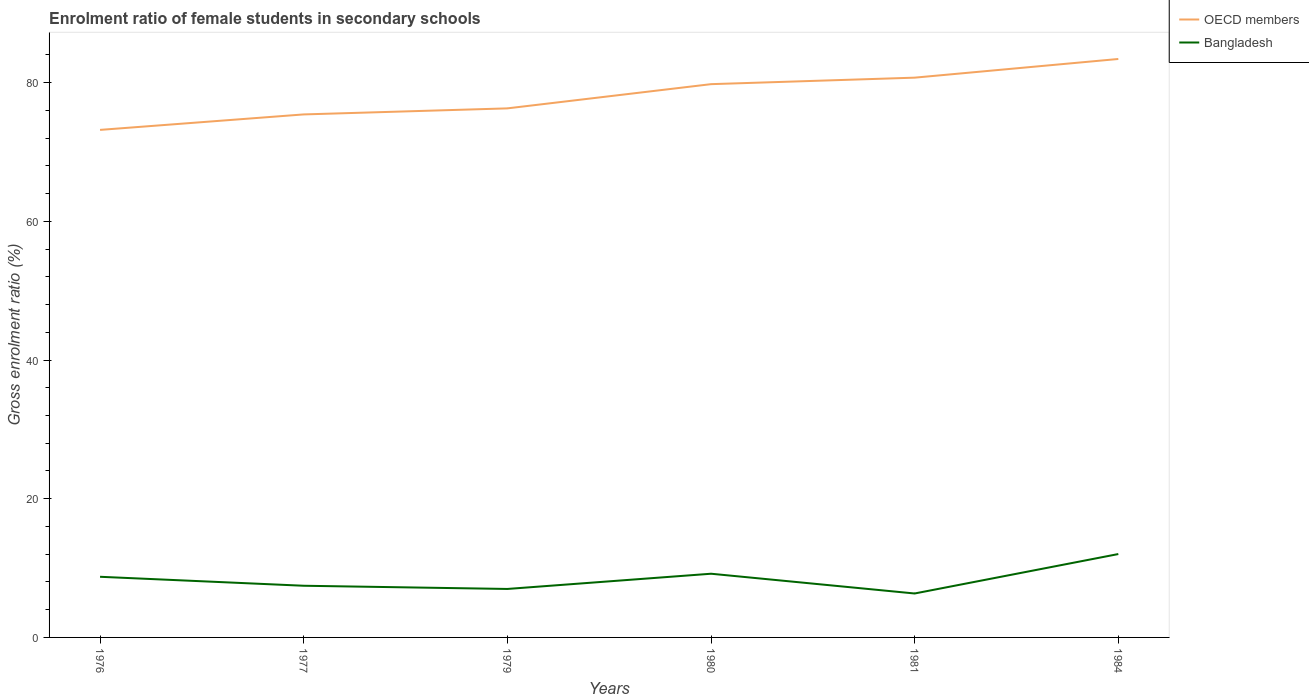Across all years, what is the maximum enrolment ratio of female students in secondary schools in Bangladesh?
Your answer should be compact. 6.34. In which year was the enrolment ratio of female students in secondary schools in Bangladesh maximum?
Ensure brevity in your answer.  1981. What is the total enrolment ratio of female students in secondary schools in Bangladesh in the graph?
Make the answer very short. -5.03. What is the difference between the highest and the second highest enrolment ratio of female students in secondary schools in Bangladesh?
Your response must be concise. 5.69. What is the difference between the highest and the lowest enrolment ratio of female students in secondary schools in OECD members?
Provide a succinct answer. 3. Is the enrolment ratio of female students in secondary schools in OECD members strictly greater than the enrolment ratio of female students in secondary schools in Bangladesh over the years?
Ensure brevity in your answer.  No. How many years are there in the graph?
Make the answer very short. 6. What is the difference between two consecutive major ticks on the Y-axis?
Make the answer very short. 20. Does the graph contain any zero values?
Keep it short and to the point. No. Where does the legend appear in the graph?
Your response must be concise. Top right. How are the legend labels stacked?
Give a very brief answer. Vertical. What is the title of the graph?
Provide a succinct answer. Enrolment ratio of female students in secondary schools. What is the Gross enrolment ratio (%) in OECD members in 1976?
Provide a succinct answer. 73.18. What is the Gross enrolment ratio (%) in Bangladesh in 1976?
Ensure brevity in your answer.  8.74. What is the Gross enrolment ratio (%) of OECD members in 1977?
Your response must be concise. 75.41. What is the Gross enrolment ratio (%) of Bangladesh in 1977?
Make the answer very short. 7.45. What is the Gross enrolment ratio (%) in OECD members in 1979?
Offer a terse response. 76.29. What is the Gross enrolment ratio (%) in Bangladesh in 1979?
Provide a succinct answer. 6.99. What is the Gross enrolment ratio (%) of OECD members in 1980?
Give a very brief answer. 79.78. What is the Gross enrolment ratio (%) in Bangladesh in 1980?
Offer a terse response. 9.18. What is the Gross enrolment ratio (%) of OECD members in 1981?
Keep it short and to the point. 80.71. What is the Gross enrolment ratio (%) of Bangladesh in 1981?
Ensure brevity in your answer.  6.34. What is the Gross enrolment ratio (%) of OECD members in 1984?
Keep it short and to the point. 83.41. What is the Gross enrolment ratio (%) in Bangladesh in 1984?
Make the answer very short. 12.02. Across all years, what is the maximum Gross enrolment ratio (%) of OECD members?
Your response must be concise. 83.41. Across all years, what is the maximum Gross enrolment ratio (%) of Bangladesh?
Your answer should be compact. 12.02. Across all years, what is the minimum Gross enrolment ratio (%) in OECD members?
Your answer should be compact. 73.18. Across all years, what is the minimum Gross enrolment ratio (%) of Bangladesh?
Make the answer very short. 6.34. What is the total Gross enrolment ratio (%) of OECD members in the graph?
Your answer should be very brief. 468.79. What is the total Gross enrolment ratio (%) of Bangladesh in the graph?
Your answer should be very brief. 50.73. What is the difference between the Gross enrolment ratio (%) of OECD members in 1976 and that in 1977?
Your answer should be compact. -2.23. What is the difference between the Gross enrolment ratio (%) in Bangladesh in 1976 and that in 1977?
Keep it short and to the point. 1.29. What is the difference between the Gross enrolment ratio (%) of OECD members in 1976 and that in 1979?
Make the answer very short. -3.1. What is the difference between the Gross enrolment ratio (%) of Bangladesh in 1976 and that in 1979?
Give a very brief answer. 1.75. What is the difference between the Gross enrolment ratio (%) of OECD members in 1976 and that in 1980?
Make the answer very short. -6.59. What is the difference between the Gross enrolment ratio (%) of Bangladesh in 1976 and that in 1980?
Offer a terse response. -0.44. What is the difference between the Gross enrolment ratio (%) in OECD members in 1976 and that in 1981?
Your response must be concise. -7.53. What is the difference between the Gross enrolment ratio (%) in Bangladesh in 1976 and that in 1981?
Offer a very short reply. 2.41. What is the difference between the Gross enrolment ratio (%) in OECD members in 1976 and that in 1984?
Make the answer very short. -10.22. What is the difference between the Gross enrolment ratio (%) in Bangladesh in 1976 and that in 1984?
Provide a short and direct response. -3.28. What is the difference between the Gross enrolment ratio (%) of OECD members in 1977 and that in 1979?
Provide a short and direct response. -0.87. What is the difference between the Gross enrolment ratio (%) in Bangladesh in 1977 and that in 1979?
Your answer should be compact. 0.46. What is the difference between the Gross enrolment ratio (%) in OECD members in 1977 and that in 1980?
Provide a short and direct response. -4.36. What is the difference between the Gross enrolment ratio (%) of Bangladesh in 1977 and that in 1980?
Make the answer very short. -1.73. What is the difference between the Gross enrolment ratio (%) in Bangladesh in 1977 and that in 1981?
Keep it short and to the point. 1.12. What is the difference between the Gross enrolment ratio (%) in OECD members in 1977 and that in 1984?
Ensure brevity in your answer.  -7.99. What is the difference between the Gross enrolment ratio (%) in Bangladesh in 1977 and that in 1984?
Provide a succinct answer. -4.57. What is the difference between the Gross enrolment ratio (%) of OECD members in 1979 and that in 1980?
Offer a terse response. -3.49. What is the difference between the Gross enrolment ratio (%) in Bangladesh in 1979 and that in 1980?
Your answer should be very brief. -2.19. What is the difference between the Gross enrolment ratio (%) of OECD members in 1979 and that in 1981?
Offer a terse response. -4.43. What is the difference between the Gross enrolment ratio (%) of Bangladesh in 1979 and that in 1981?
Provide a succinct answer. 0.65. What is the difference between the Gross enrolment ratio (%) of OECD members in 1979 and that in 1984?
Provide a short and direct response. -7.12. What is the difference between the Gross enrolment ratio (%) of Bangladesh in 1979 and that in 1984?
Provide a short and direct response. -5.03. What is the difference between the Gross enrolment ratio (%) of OECD members in 1980 and that in 1981?
Give a very brief answer. -0.94. What is the difference between the Gross enrolment ratio (%) in Bangladesh in 1980 and that in 1981?
Your answer should be very brief. 2.85. What is the difference between the Gross enrolment ratio (%) in OECD members in 1980 and that in 1984?
Ensure brevity in your answer.  -3.63. What is the difference between the Gross enrolment ratio (%) of Bangladesh in 1980 and that in 1984?
Offer a terse response. -2.84. What is the difference between the Gross enrolment ratio (%) in OECD members in 1981 and that in 1984?
Provide a short and direct response. -2.69. What is the difference between the Gross enrolment ratio (%) in Bangladesh in 1981 and that in 1984?
Make the answer very short. -5.69. What is the difference between the Gross enrolment ratio (%) in OECD members in 1976 and the Gross enrolment ratio (%) in Bangladesh in 1977?
Give a very brief answer. 65.73. What is the difference between the Gross enrolment ratio (%) of OECD members in 1976 and the Gross enrolment ratio (%) of Bangladesh in 1979?
Provide a short and direct response. 66.19. What is the difference between the Gross enrolment ratio (%) in OECD members in 1976 and the Gross enrolment ratio (%) in Bangladesh in 1980?
Give a very brief answer. 64. What is the difference between the Gross enrolment ratio (%) of OECD members in 1976 and the Gross enrolment ratio (%) of Bangladesh in 1981?
Make the answer very short. 66.85. What is the difference between the Gross enrolment ratio (%) of OECD members in 1976 and the Gross enrolment ratio (%) of Bangladesh in 1984?
Provide a succinct answer. 61.16. What is the difference between the Gross enrolment ratio (%) in OECD members in 1977 and the Gross enrolment ratio (%) in Bangladesh in 1979?
Your answer should be compact. 68.42. What is the difference between the Gross enrolment ratio (%) of OECD members in 1977 and the Gross enrolment ratio (%) of Bangladesh in 1980?
Keep it short and to the point. 66.23. What is the difference between the Gross enrolment ratio (%) in OECD members in 1977 and the Gross enrolment ratio (%) in Bangladesh in 1981?
Offer a very short reply. 69.08. What is the difference between the Gross enrolment ratio (%) in OECD members in 1977 and the Gross enrolment ratio (%) in Bangladesh in 1984?
Provide a short and direct response. 63.39. What is the difference between the Gross enrolment ratio (%) of OECD members in 1979 and the Gross enrolment ratio (%) of Bangladesh in 1980?
Your answer should be very brief. 67.1. What is the difference between the Gross enrolment ratio (%) in OECD members in 1979 and the Gross enrolment ratio (%) in Bangladesh in 1981?
Your response must be concise. 69.95. What is the difference between the Gross enrolment ratio (%) in OECD members in 1979 and the Gross enrolment ratio (%) in Bangladesh in 1984?
Ensure brevity in your answer.  64.26. What is the difference between the Gross enrolment ratio (%) in OECD members in 1980 and the Gross enrolment ratio (%) in Bangladesh in 1981?
Offer a terse response. 73.44. What is the difference between the Gross enrolment ratio (%) of OECD members in 1980 and the Gross enrolment ratio (%) of Bangladesh in 1984?
Your answer should be very brief. 67.75. What is the difference between the Gross enrolment ratio (%) in OECD members in 1981 and the Gross enrolment ratio (%) in Bangladesh in 1984?
Provide a short and direct response. 68.69. What is the average Gross enrolment ratio (%) of OECD members per year?
Provide a succinct answer. 78.13. What is the average Gross enrolment ratio (%) in Bangladesh per year?
Your response must be concise. 8.45. In the year 1976, what is the difference between the Gross enrolment ratio (%) in OECD members and Gross enrolment ratio (%) in Bangladesh?
Make the answer very short. 64.44. In the year 1977, what is the difference between the Gross enrolment ratio (%) of OECD members and Gross enrolment ratio (%) of Bangladesh?
Provide a short and direct response. 67.96. In the year 1979, what is the difference between the Gross enrolment ratio (%) of OECD members and Gross enrolment ratio (%) of Bangladesh?
Provide a short and direct response. 69.3. In the year 1980, what is the difference between the Gross enrolment ratio (%) in OECD members and Gross enrolment ratio (%) in Bangladesh?
Provide a short and direct response. 70.59. In the year 1981, what is the difference between the Gross enrolment ratio (%) of OECD members and Gross enrolment ratio (%) of Bangladesh?
Provide a succinct answer. 74.38. In the year 1984, what is the difference between the Gross enrolment ratio (%) in OECD members and Gross enrolment ratio (%) in Bangladesh?
Provide a short and direct response. 71.39. What is the ratio of the Gross enrolment ratio (%) in OECD members in 1976 to that in 1977?
Provide a succinct answer. 0.97. What is the ratio of the Gross enrolment ratio (%) in Bangladesh in 1976 to that in 1977?
Provide a succinct answer. 1.17. What is the ratio of the Gross enrolment ratio (%) in OECD members in 1976 to that in 1979?
Provide a succinct answer. 0.96. What is the ratio of the Gross enrolment ratio (%) of Bangladesh in 1976 to that in 1979?
Your answer should be compact. 1.25. What is the ratio of the Gross enrolment ratio (%) of OECD members in 1976 to that in 1980?
Your answer should be very brief. 0.92. What is the ratio of the Gross enrolment ratio (%) in OECD members in 1976 to that in 1981?
Provide a short and direct response. 0.91. What is the ratio of the Gross enrolment ratio (%) of Bangladesh in 1976 to that in 1981?
Make the answer very short. 1.38. What is the ratio of the Gross enrolment ratio (%) in OECD members in 1976 to that in 1984?
Give a very brief answer. 0.88. What is the ratio of the Gross enrolment ratio (%) of Bangladesh in 1976 to that in 1984?
Your response must be concise. 0.73. What is the ratio of the Gross enrolment ratio (%) in Bangladesh in 1977 to that in 1979?
Your response must be concise. 1.07. What is the ratio of the Gross enrolment ratio (%) in OECD members in 1977 to that in 1980?
Your response must be concise. 0.95. What is the ratio of the Gross enrolment ratio (%) of Bangladesh in 1977 to that in 1980?
Offer a very short reply. 0.81. What is the ratio of the Gross enrolment ratio (%) in OECD members in 1977 to that in 1981?
Keep it short and to the point. 0.93. What is the ratio of the Gross enrolment ratio (%) of Bangladesh in 1977 to that in 1981?
Offer a terse response. 1.18. What is the ratio of the Gross enrolment ratio (%) in OECD members in 1977 to that in 1984?
Your answer should be very brief. 0.9. What is the ratio of the Gross enrolment ratio (%) of Bangladesh in 1977 to that in 1984?
Your answer should be compact. 0.62. What is the ratio of the Gross enrolment ratio (%) in OECD members in 1979 to that in 1980?
Keep it short and to the point. 0.96. What is the ratio of the Gross enrolment ratio (%) of Bangladesh in 1979 to that in 1980?
Your answer should be compact. 0.76. What is the ratio of the Gross enrolment ratio (%) of OECD members in 1979 to that in 1981?
Offer a very short reply. 0.95. What is the ratio of the Gross enrolment ratio (%) of Bangladesh in 1979 to that in 1981?
Your answer should be very brief. 1.1. What is the ratio of the Gross enrolment ratio (%) in OECD members in 1979 to that in 1984?
Give a very brief answer. 0.91. What is the ratio of the Gross enrolment ratio (%) in Bangladesh in 1979 to that in 1984?
Your answer should be compact. 0.58. What is the ratio of the Gross enrolment ratio (%) in OECD members in 1980 to that in 1981?
Provide a short and direct response. 0.99. What is the ratio of the Gross enrolment ratio (%) of Bangladesh in 1980 to that in 1981?
Provide a short and direct response. 1.45. What is the ratio of the Gross enrolment ratio (%) of OECD members in 1980 to that in 1984?
Keep it short and to the point. 0.96. What is the ratio of the Gross enrolment ratio (%) in Bangladesh in 1980 to that in 1984?
Your response must be concise. 0.76. What is the ratio of the Gross enrolment ratio (%) of OECD members in 1981 to that in 1984?
Your response must be concise. 0.97. What is the ratio of the Gross enrolment ratio (%) in Bangladesh in 1981 to that in 1984?
Provide a succinct answer. 0.53. What is the difference between the highest and the second highest Gross enrolment ratio (%) in OECD members?
Give a very brief answer. 2.69. What is the difference between the highest and the second highest Gross enrolment ratio (%) in Bangladesh?
Provide a short and direct response. 2.84. What is the difference between the highest and the lowest Gross enrolment ratio (%) of OECD members?
Provide a succinct answer. 10.22. What is the difference between the highest and the lowest Gross enrolment ratio (%) of Bangladesh?
Your answer should be compact. 5.69. 